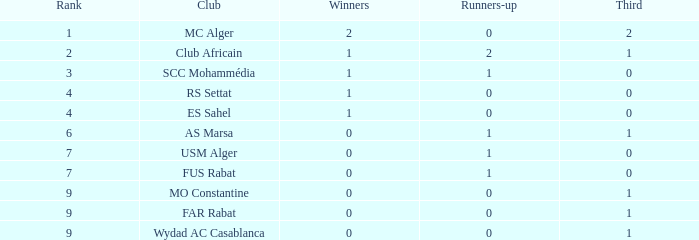Which Third has Runners-up of 0, and Winners of 0, and a Club of far rabat? 1.0. 